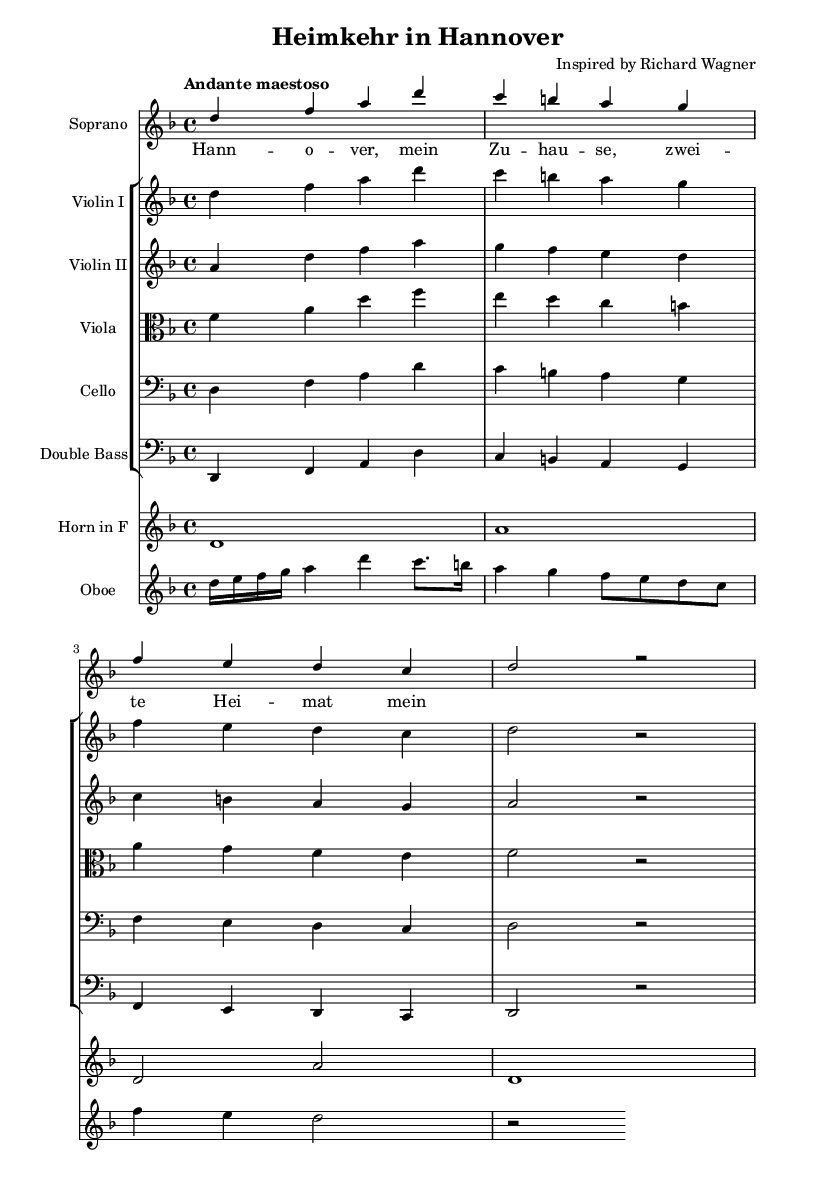What is the key signature of this music? The key signature is D minor, which includes one flat (B flat) and signifies that the piece is in a minor tonality.
Answer: D minor What is the time signature of this music? The time signature is 4/4, indicating that there are four beats in each measure, and the quarter note gets one beat.
Answer: 4/4 What is the tempo marking in this music? The tempo marking is Andante maestoso, signifying a moderately slow tempo with a majestic character.
Answer: Andante maestoso How many sections of music are there for the soprano voice? The soprano voice has two distinct sections in the written sheet music. One can identify this by counting the phrase structures present.
Answer: Two What instruments are included in the orchestration of this piece? The orchestration includes Soprano, Violin I, Violin II, Viola, Cello, Double Bass, Horn, and Oboe, as evident from the staff listings.
Answer: Soprano, Violin I, Violin II, Viola, Cello, Double Bass, Horn, Oboe What is the climax note of the soprano part based on the provided music? The climax note of the soprano part is D, as it appears prominently at the beginning and acts as a focal point in the melodic line.
Answer: D What specific opera theme does the title suggest this music relates to? The title "Heimkehr in Hannover" suggests a homecoming theme, which is often explored within the context of longing and reunion found in many German operas.
Answer: Homecoming 